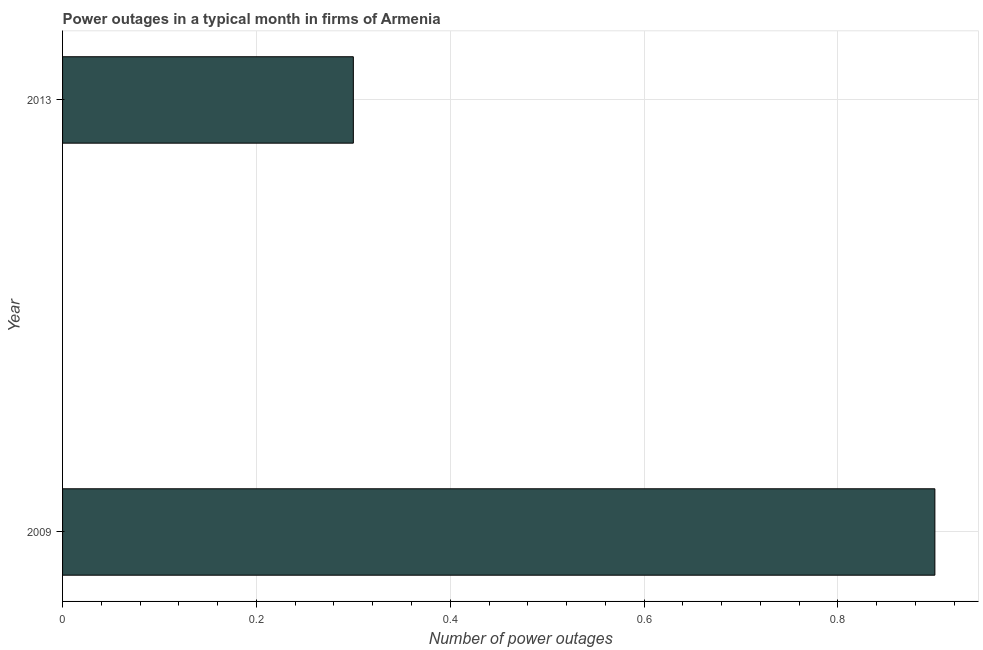Does the graph contain any zero values?
Give a very brief answer. No. Does the graph contain grids?
Offer a very short reply. Yes. What is the title of the graph?
Offer a terse response. Power outages in a typical month in firms of Armenia. What is the label or title of the X-axis?
Provide a succinct answer. Number of power outages. What is the number of power outages in 2013?
Provide a succinct answer. 0.3. What is the sum of the number of power outages?
Offer a terse response. 1.2. What is the difference between the number of power outages in 2009 and 2013?
Offer a terse response. 0.6. In how many years, is the number of power outages greater than 0.16 ?
Your answer should be compact. 2. Do a majority of the years between 2009 and 2013 (inclusive) have number of power outages greater than 0.28 ?
Offer a very short reply. Yes. What is the ratio of the number of power outages in 2009 to that in 2013?
Provide a short and direct response. 3. What is the difference between two consecutive major ticks on the X-axis?
Provide a short and direct response. 0.2. Are the values on the major ticks of X-axis written in scientific E-notation?
Your response must be concise. No. What is the ratio of the Number of power outages in 2009 to that in 2013?
Offer a very short reply. 3. 